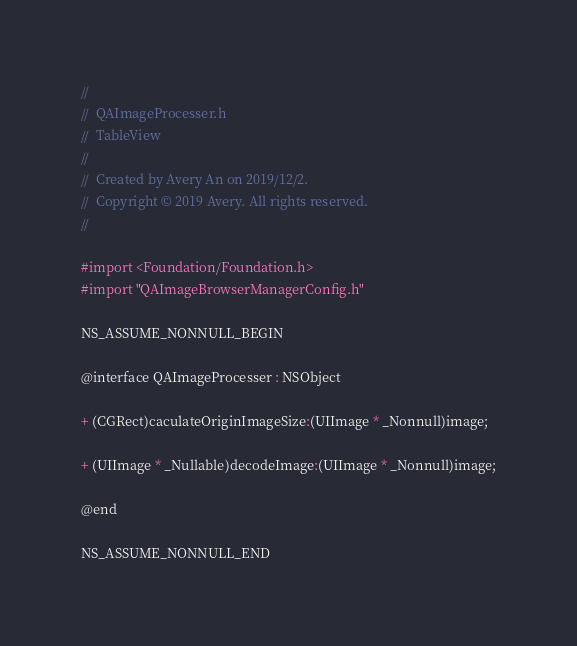<code> <loc_0><loc_0><loc_500><loc_500><_C_>//
//  QAImageProcesser.h
//  TableView
//
//  Created by Avery An on 2019/12/2.
//  Copyright © 2019 Avery. All rights reserved.
//

#import <Foundation/Foundation.h>
#import "QAImageBrowserManagerConfig.h"

NS_ASSUME_NONNULL_BEGIN

@interface QAImageProcesser : NSObject

+ (CGRect)caculateOriginImageSize:(UIImage * _Nonnull)image;

+ (UIImage * _Nullable)decodeImage:(UIImage * _Nonnull)image;

@end

NS_ASSUME_NONNULL_END
</code> 